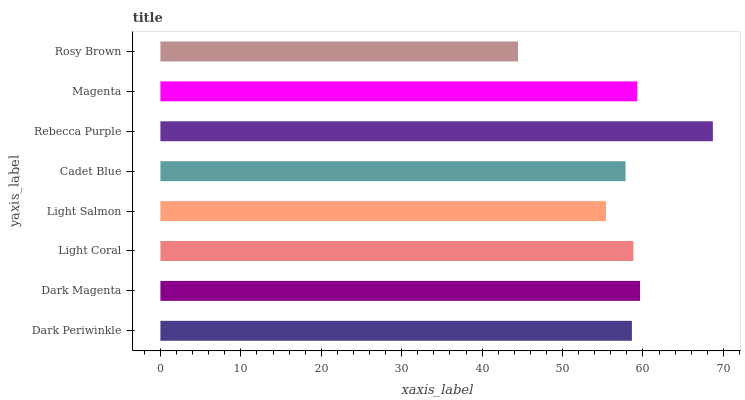Is Rosy Brown the minimum?
Answer yes or no. Yes. Is Rebecca Purple the maximum?
Answer yes or no. Yes. Is Dark Magenta the minimum?
Answer yes or no. No. Is Dark Magenta the maximum?
Answer yes or no. No. Is Dark Magenta greater than Dark Periwinkle?
Answer yes or no. Yes. Is Dark Periwinkle less than Dark Magenta?
Answer yes or no. Yes. Is Dark Periwinkle greater than Dark Magenta?
Answer yes or no. No. Is Dark Magenta less than Dark Periwinkle?
Answer yes or no. No. Is Light Coral the high median?
Answer yes or no. Yes. Is Dark Periwinkle the low median?
Answer yes or no. Yes. Is Rebecca Purple the high median?
Answer yes or no. No. Is Light Salmon the low median?
Answer yes or no. No. 